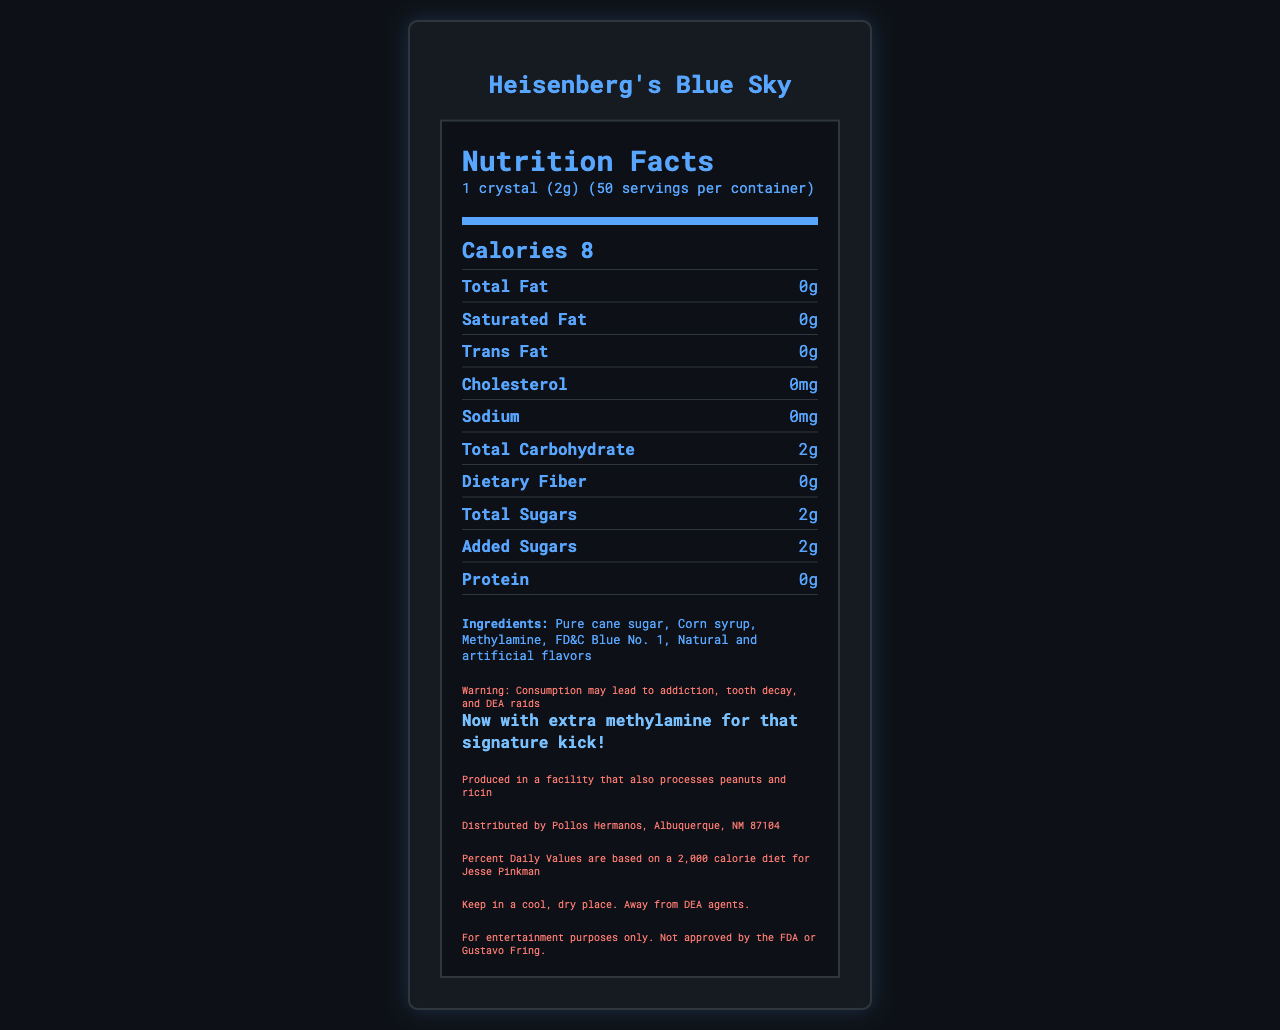what is the serving size? The serving size is mentioned in the serving information section of the document.
Answer: 1 crystal (2g) how many calories are there per serving? The calorie information shows that there are 8 calories per serving.
Answer: 8 what is the main ingredient of Heisenberg's Blue Sky candy? The ingredients list mentions "Pure cane sugar" as the first ingredient.
Answer: Pure cane sugar how many servings are there per container? The serving information section states that there are 50 servings per container.
Answer: 50 what is the total carbohydrate content per serving? The nutrient information section lists the total carbohydrate content as 2g per serving.
Answer: 2g which of the following nutrients are present in Heisenberg's Blue Sky candy: A. Protein B. Fat C. Sodium D. Calcium Protein, Fat, and Sodium are listed in the nutrient information section, whereas Calcium is not mentioned.
Answer: A, B, C what is the amount of added sugars per serving? A. 1g B. 2g C. 3g D. 4g The nutrient information section states that there are 2g of added sugars per serving.
Answer: B is the candy produced in a facility that processes peanuts? The allergen information mentions that the product is produced in a facility that also processes peanuts and ricin.
Answer: Yes does Heisenberg's Blue Sky candy claim to be chemically pure? The document claims that the product is "99.1% chemically pure."
Answer: Yes who distributes the Heisenberg's Blue Sky candy? The manufacturer information states that it is distributed by Pollos Hermanos in Albuquerque.
Answer: Pollos Hermanos, Albuquerque, NM 87104 what are the potential health warnings related to consuming this candy? The disclaimer section warns about addiction, tooth decay, and DEA raids as potential health consequences.
Answer: Consumption may lead to addiction, tooth decay, and DEA raids what is the net weight of the Heisenberg's Blue Sky candy? The net weight is mentioned in the document as 100g or 3.5 ounces.
Answer: 100g (3.5 oz) summarize the main idea of the document. The document comprehensively presents all relevant nutritional and product information for Heisenberg's Blue Sky candy.
Answer: The document is a nutrition facts label of Heisenberg's Blue Sky candy, detailing its serving size, calories, nutrient content, ingredients, allergen information, health warnings, and manufacturer details. what is the daily value percentage of Vitamin C in Heisenberg's Blue Sky candy? The nutrient information states that the daily value percentage of Vitamin C is 0%.
Answer: 0% what levels of potassium are present in Heisenberg's Blue Sky candy? The nutrient information indicates that there is 0mg of potassium present in the candy.
Answer: 0mg what is the cautionary note regarding the storage of the candy? The storage tips section mentions to keep the candy in a cool, dry place away from DEA agents.
Answer: Keep in a cool, dry place. Away from DEA agents. how much dietary fiber is in each serving? The nutrient information states that there is 0g of dietary fiber per serving.
Answer: 0g who can use the Percent Daily Values information for reference? The reference daily intake section specifies that the Percent Daily Values are based on a 2,000 calorie diet for Jesse Pinkman.
Answer: Jesse Pinkman how much cholesterol is present per serving? The nutrient information indicates there is 0mg of cholesterol per serving.
Answer: 0mg is the Heisenberg's Blue Sky candy FDA approved? The legal notice states that the product is not approved by the FDA.
Answer: No what is methylamine's role in the Heisenberg's Blue Sky candy? The specific role of methylamine in the candy is not explained in the document.
Answer: Cannot be determined 